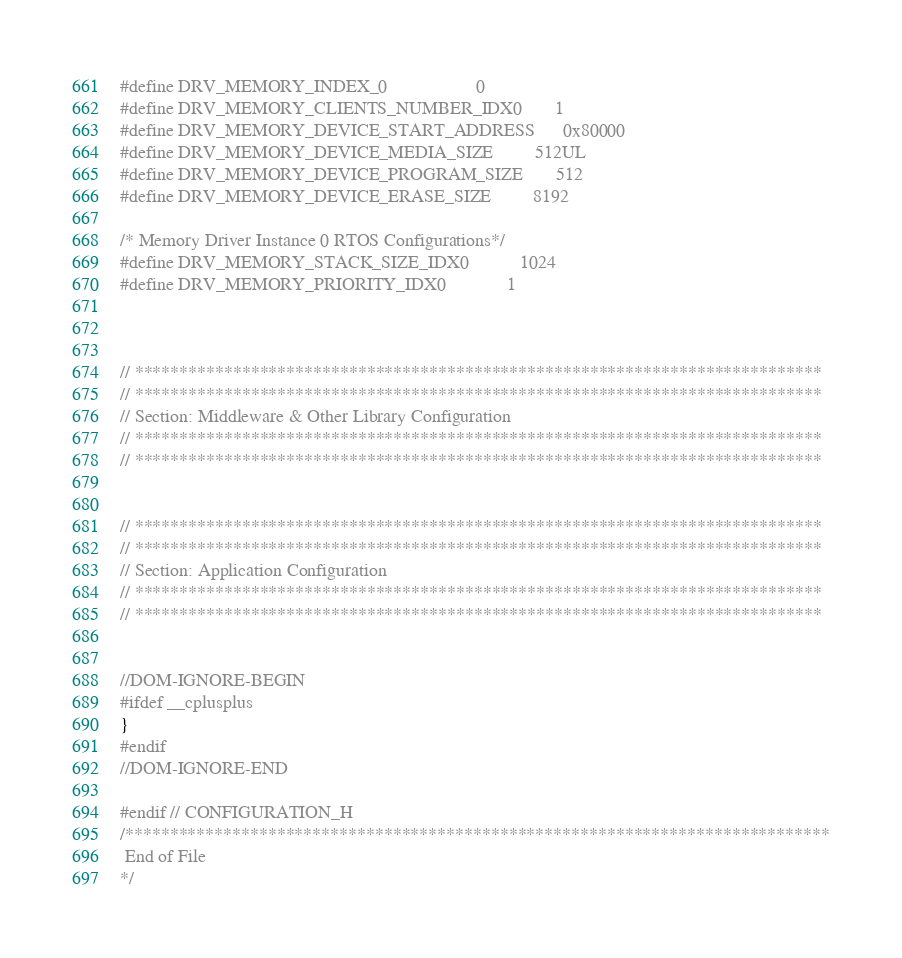Convert code to text. <code><loc_0><loc_0><loc_500><loc_500><_C_>#define DRV_MEMORY_INDEX_0                   0
#define DRV_MEMORY_CLIENTS_NUMBER_IDX0       1
#define DRV_MEMORY_DEVICE_START_ADDRESS      0x80000
#define DRV_MEMORY_DEVICE_MEDIA_SIZE         512UL
#define DRV_MEMORY_DEVICE_PROGRAM_SIZE       512
#define DRV_MEMORY_DEVICE_ERASE_SIZE         8192

/* Memory Driver Instance 0 RTOS Configurations*/
#define DRV_MEMORY_STACK_SIZE_IDX0           1024
#define DRV_MEMORY_PRIORITY_IDX0             1



// *****************************************************************************
// *****************************************************************************
// Section: Middleware & Other Library Configuration
// *****************************************************************************
// *****************************************************************************


// *****************************************************************************
// *****************************************************************************
// Section: Application Configuration
// *****************************************************************************
// *****************************************************************************


//DOM-IGNORE-BEGIN
#ifdef __cplusplus
}
#endif
//DOM-IGNORE-END

#endif // CONFIGURATION_H
/*******************************************************************************
 End of File
*/
</code> 